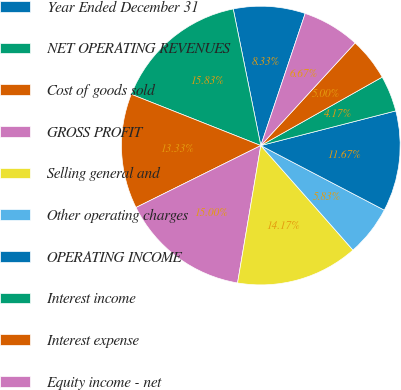Convert chart to OTSL. <chart><loc_0><loc_0><loc_500><loc_500><pie_chart><fcel>Year Ended December 31<fcel>NET OPERATING REVENUES<fcel>Cost of goods sold<fcel>GROSS PROFIT<fcel>Selling general and<fcel>Other operating charges<fcel>OPERATING INCOME<fcel>Interest income<fcel>Interest expense<fcel>Equity income - net<nl><fcel>8.33%<fcel>15.83%<fcel>13.33%<fcel>15.0%<fcel>14.17%<fcel>5.83%<fcel>11.67%<fcel>4.17%<fcel>5.0%<fcel>6.67%<nl></chart> 